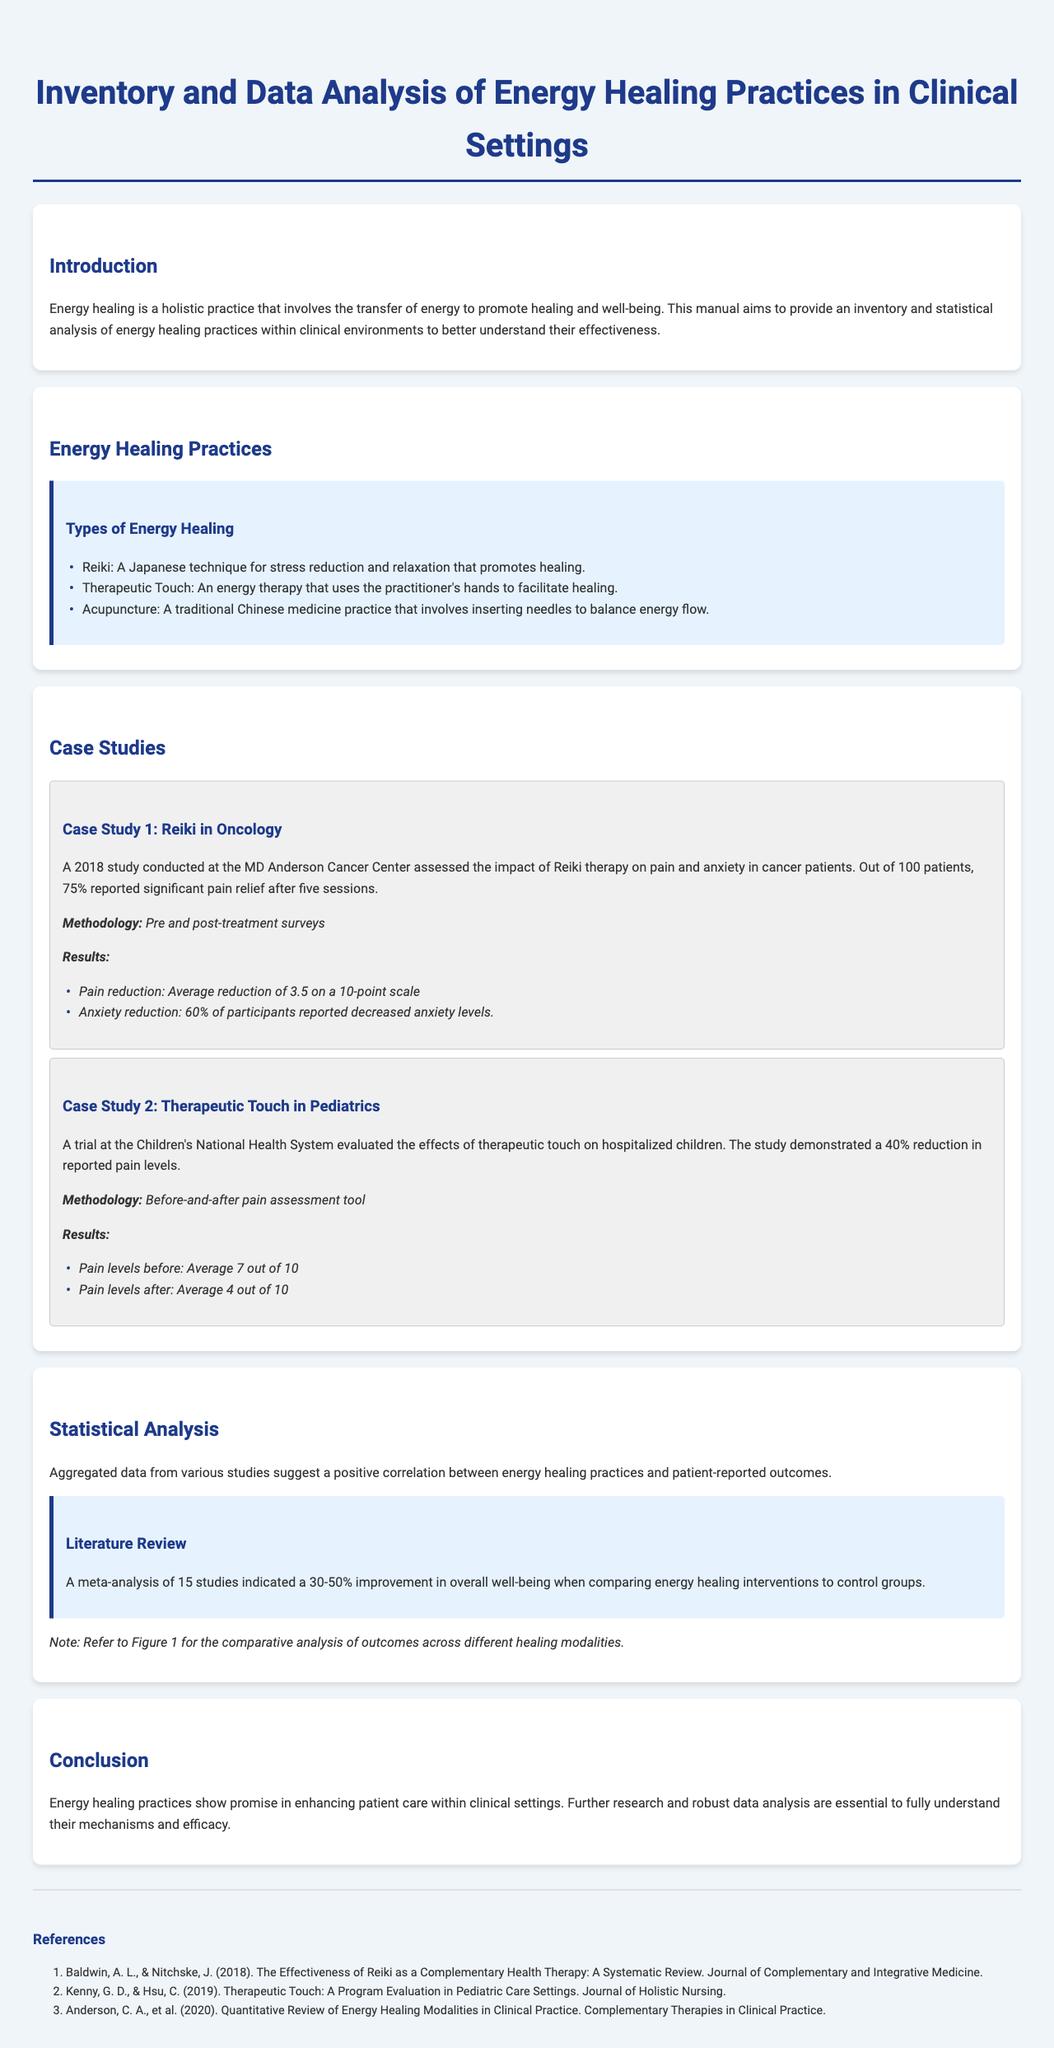What is the primary focus of this manual? The manual's primary focus is to provide an inventory and statistical analysis of energy healing practices within clinical environments to better understand their effectiveness.
Answer: Effectiveness What percentage of oncology patients reported pain relief after Reiki therapy? The document states that out of 100 patients, 75% reported significant pain relief after five sessions of Reiki therapy.
Answer: 75% How much did pain levels drop in the pediatric therapeutic touch case study? The average pain level before therapeutic touch was 7 out of 10, dropping to an average of 4 out of 10 after treatment, indicating a reduction of 3.
Answer: 3 What types of energy healing are mentioned? The document lists Reiki, Therapeutic Touch, and Acupuncture as examples of energy healing practices.
Answer: Reiki, Therapeutic Touch, Acupuncture What was the improvement range in overall well-being noted in the meta-analysis? The literature review indicates a 30-50% improvement in overall well-being when comparing energy healing interventions to control groups.
Answer: 30-50% What was the sample size of the Reiki study conducted at MD Anderson Cancer Center? The case study states that the sample size for the Reiki study was 100 patients.
Answer: 100 In which year was the Reiki study conducted? The document mentions that the study on Reiki in oncology was conducted in 2018.
Answer: 2018 What is emphasized as essential for understanding energy healing practices? The conclusion highlights that further research and robust data analysis are essential to fully understand the mechanisms and efficacy of energy healing practices.
Answer: Further research and robust data analysis What average reduction in anxiety levels was reported in the Reiki case study? The document states that 60% of participants reported decreased anxiety levels after Reiki therapy.
Answer: 60% 